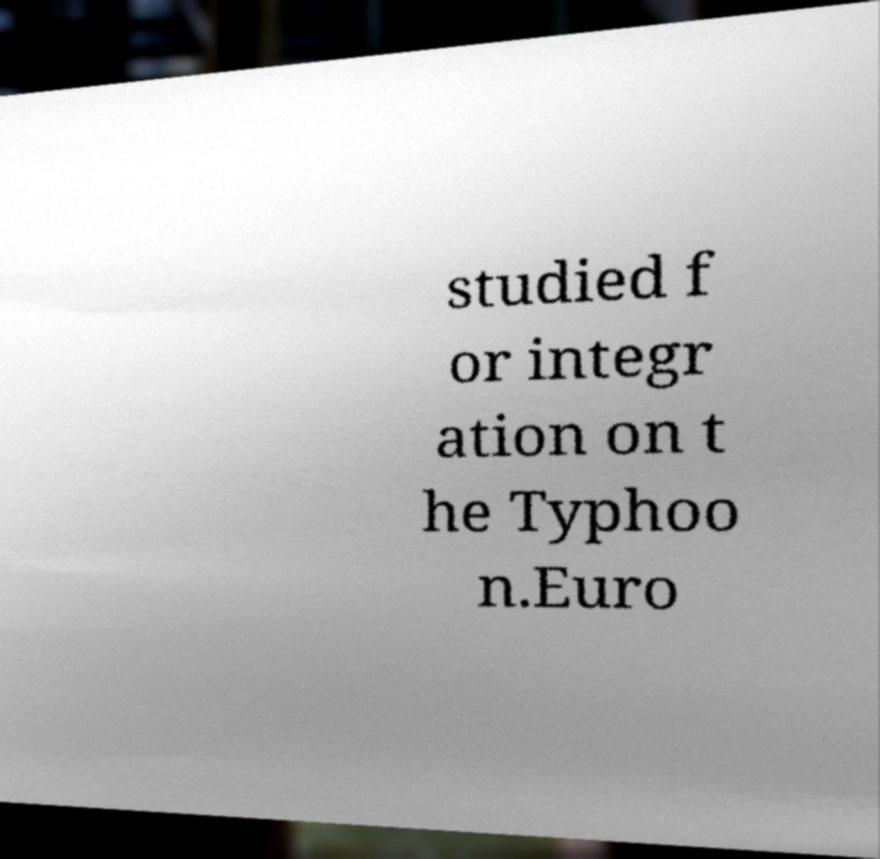Please identify and transcribe the text found in this image. studied f or integr ation on t he Typhoo n.Euro 